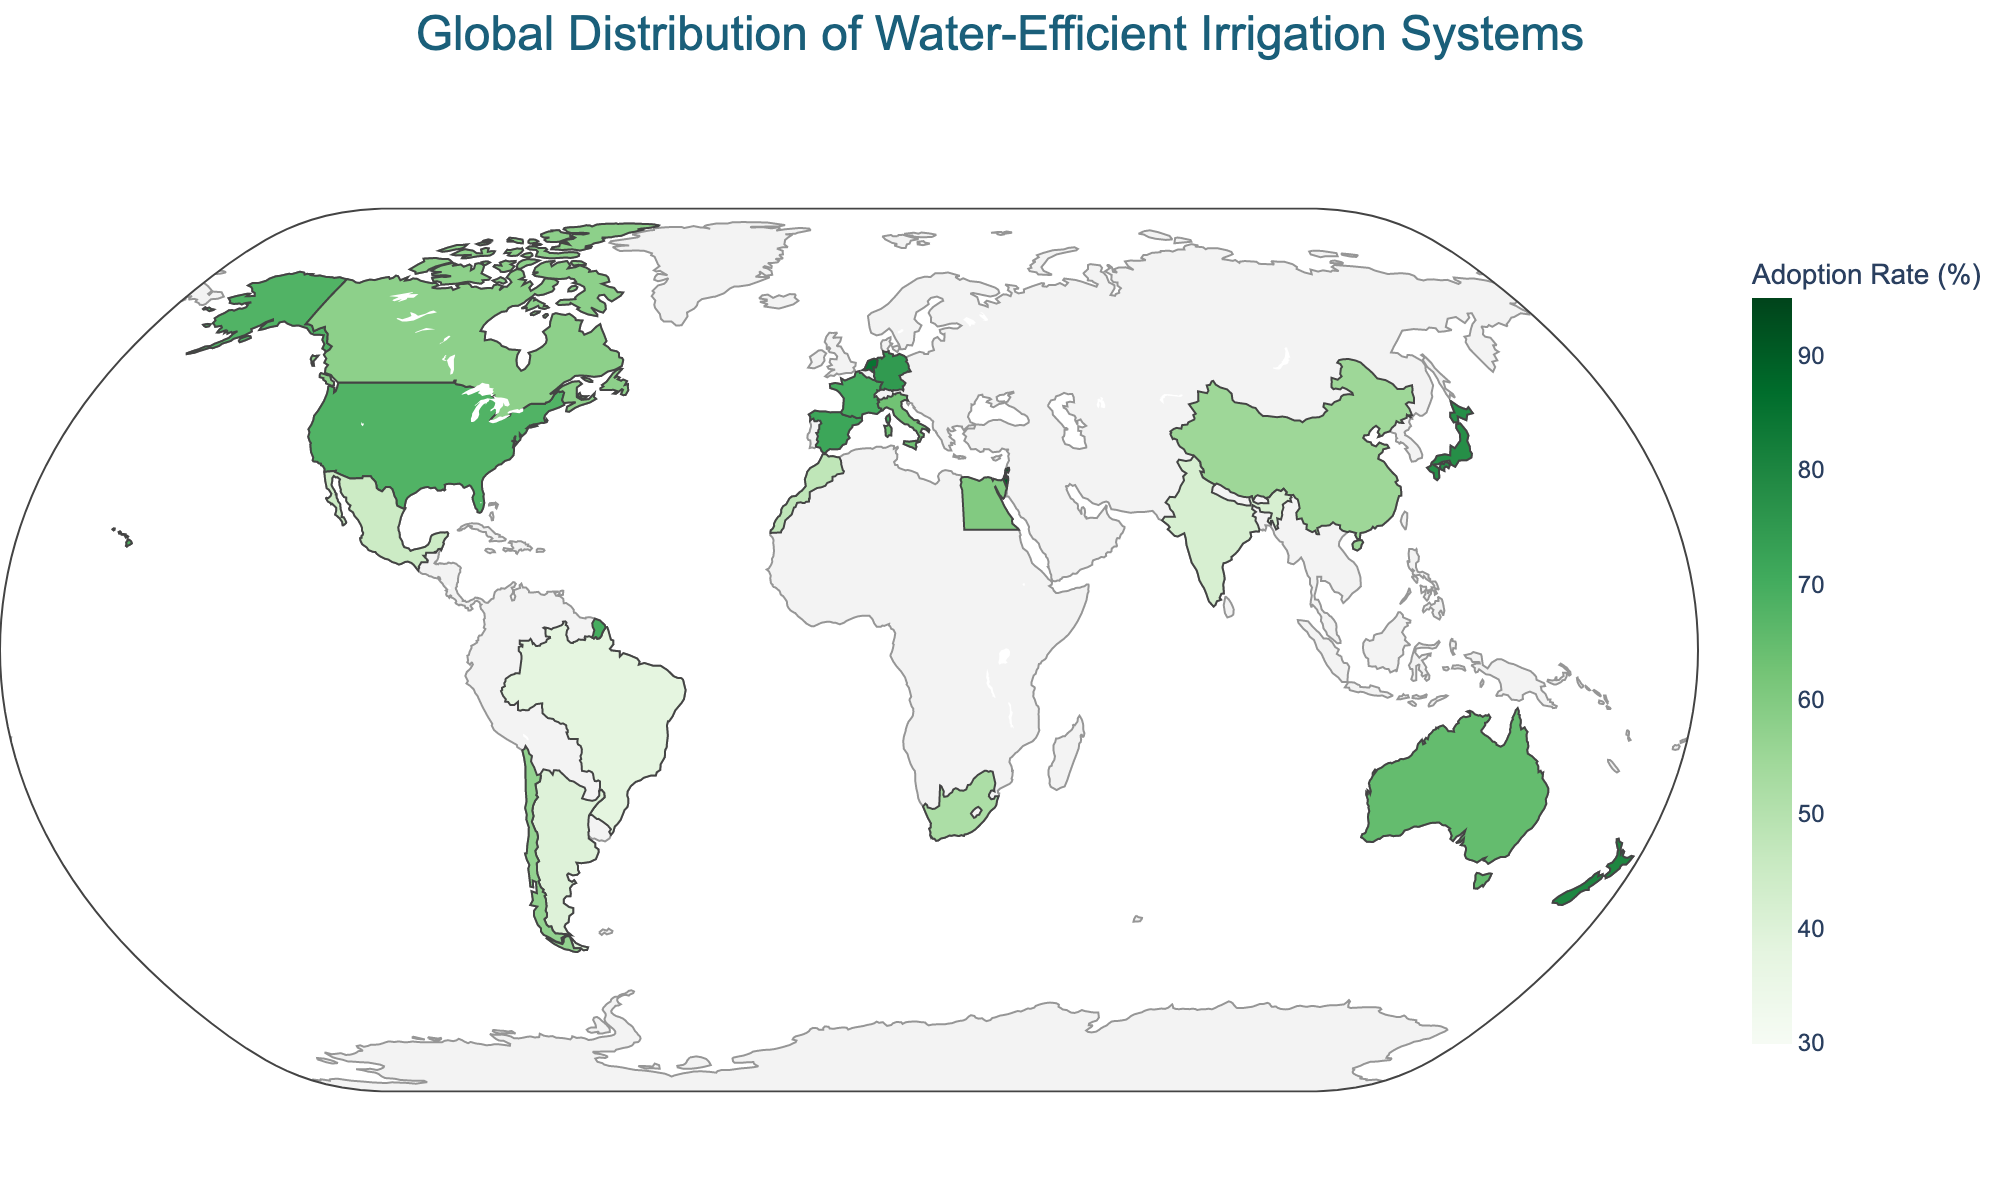How many countries are represented on the map? To find the number of countries represented, count the unique data points listed in the figure. These are the 20 countries mentioned in the data.
Answer: 20 Which country has the highest adoption rate of water-efficient irrigation systems? Check the figure's color scale and identify the country with the darkest green shade. In this case, Israel has the highest rate at 90%.
Answer: Israel What is the range of water-efficient irrigation adoption rates represented in the map? Locate the color bar to find the minimum and maximum values, which are from 30% to 95%. This range covers all the countries displayed in the figure.
Answer: 30% to 95% How does the adoption rate in Mexico compare to Brazil? Look at the adoption rates for both Mexico and Brazil. Mexico has a rate of 45%, while Brazil has a rate of 38%. Thus, Mexico has a higher adoption rate.
Answer: Mexico has a higher adoption rate What is the average adoption rate of water-efficient irrigation systems in Europe, based on the countries shown? Identify the European countries listed in the figure (Spain, Netherlands, France, Italy, Germany). Add their adoption rates: 72 + 85 + 70 + 63 + 75 = 365, then divide by the number of countries, which is 5. The average is 365/5 = 73.
Answer: 73% Which country in Africa has the highest adoption rate of water-efficient irrigation systems? Look at the African countries and compare their adoption rates. Egypt (60%) and Morocco (48%) are the countries listed, so Egypt has the highest rate.
Answer: Egypt What proportion of countries have an adoption rate above 60%? Count the number of countries with adoption rates above 60%: USA, Israel, Spain, Australia, Japan, Netherlands, France, Germany, New Zealand (9 countries out of 20). The proportion is 9/20.
Answer: 45% What is the median adoption rate for the countries listed? To find the median, sort the adoption rates first and then pick the middle value. Sorted rates: 38, 40, 42, 45, 48, 52, 55, 57, 58, 60, 63, 65, 68, 70, 72, 75, 78, 80, 85, 90. The median is the average of the 10th and 11th values (60+63)/2.
Answer: 61.5% Which countries have an adoption rate between 50% and 65%? Locate the countries with adoption rates between these values. They are South Africa (52%), China (55%), Egypt (60%), and Chile (57%).
Answer: South Africa, China, Egypt, Chile What is the difference in adoption rate between the United States and Japan? Find the adoption rates for both countries: the USA is at 68% and Japan at 78%. The difference between them is 78 - 68.
Answer: 10% 